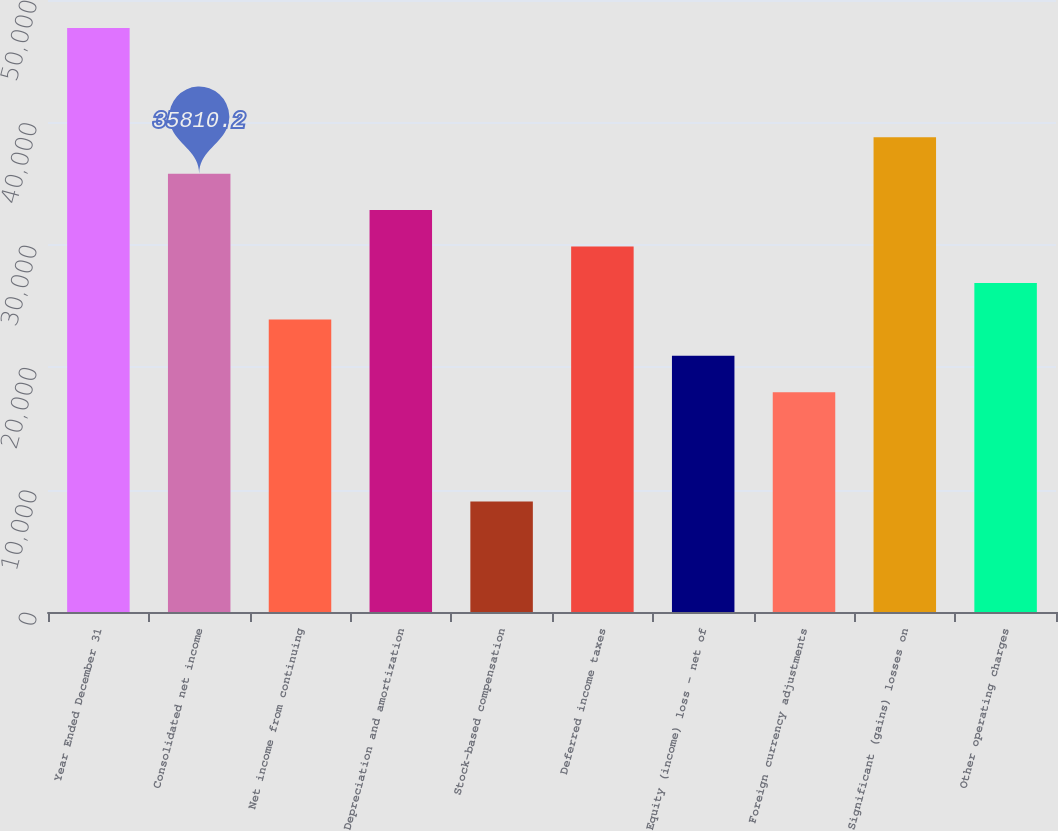<chart> <loc_0><loc_0><loc_500><loc_500><bar_chart><fcel>Year Ended December 31<fcel>Consolidated net income<fcel>Net income from continuing<fcel>Depreciation and amortization<fcel>Stock-based compensation<fcel>Deferred income taxes<fcel>Equity (income) loss - net of<fcel>Foreign currency adjustments<fcel>Significant (gains) losses on<fcel>Other operating charges<nl><fcel>47716.6<fcel>35810.2<fcel>23903.8<fcel>32833.6<fcel>9020.8<fcel>29857<fcel>20927.2<fcel>17950.6<fcel>38786.8<fcel>26880.4<nl></chart> 